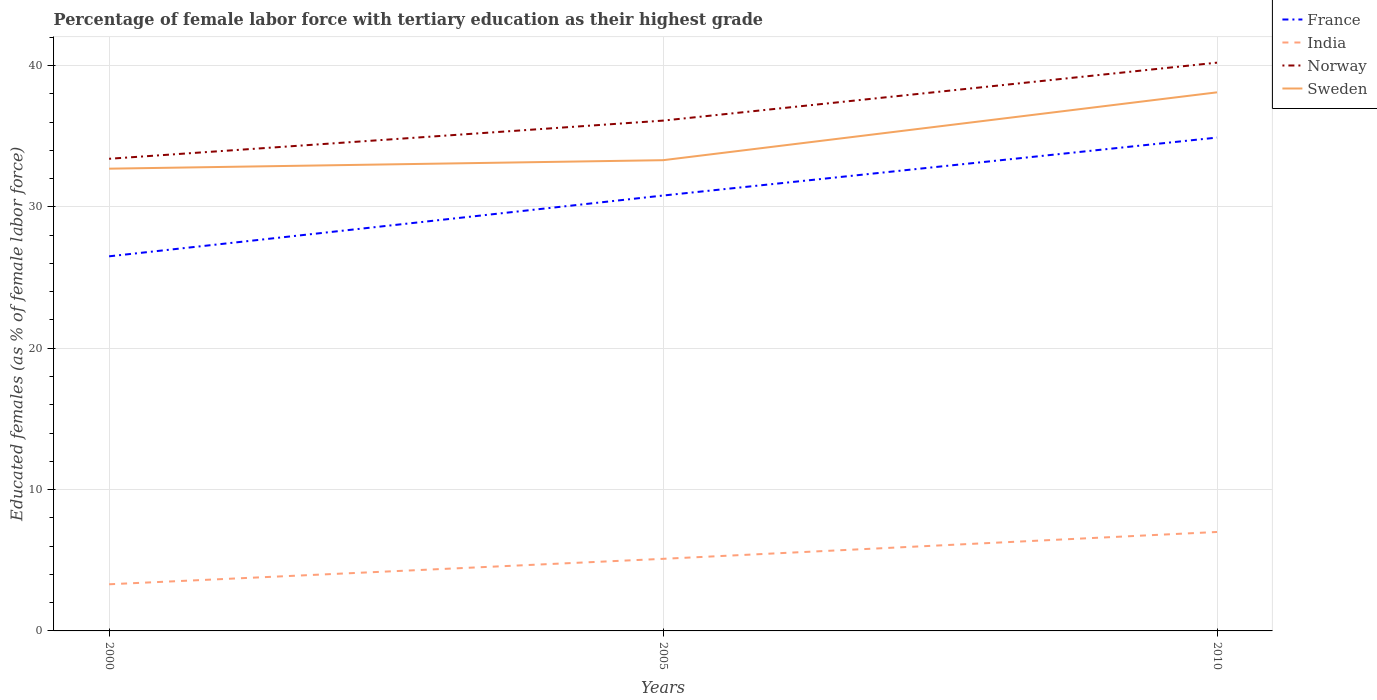Is the number of lines equal to the number of legend labels?
Make the answer very short. Yes. Across all years, what is the maximum percentage of female labor force with tertiary education in Sweden?
Keep it short and to the point. 32.7. In which year was the percentage of female labor force with tertiary education in Norway maximum?
Make the answer very short. 2000. What is the total percentage of female labor force with tertiary education in Sweden in the graph?
Give a very brief answer. -0.6. What is the difference between the highest and the second highest percentage of female labor force with tertiary education in France?
Give a very brief answer. 8.4. What is the difference between the highest and the lowest percentage of female labor force with tertiary education in Norway?
Offer a terse response. 1. Is the percentage of female labor force with tertiary education in India strictly greater than the percentage of female labor force with tertiary education in Sweden over the years?
Keep it short and to the point. Yes. How many lines are there?
Your response must be concise. 4. How many years are there in the graph?
Give a very brief answer. 3. Does the graph contain any zero values?
Your answer should be very brief. No. Does the graph contain grids?
Provide a short and direct response. Yes. Where does the legend appear in the graph?
Provide a succinct answer. Top right. How are the legend labels stacked?
Keep it short and to the point. Vertical. What is the title of the graph?
Provide a short and direct response. Percentage of female labor force with tertiary education as their highest grade. What is the label or title of the Y-axis?
Keep it short and to the point. Educated females (as % of female labor force). What is the Educated females (as % of female labor force) in France in 2000?
Give a very brief answer. 26.5. What is the Educated females (as % of female labor force) of India in 2000?
Provide a short and direct response. 3.3. What is the Educated females (as % of female labor force) of Norway in 2000?
Offer a terse response. 33.4. What is the Educated females (as % of female labor force) of Sweden in 2000?
Make the answer very short. 32.7. What is the Educated females (as % of female labor force) in France in 2005?
Your response must be concise. 30.8. What is the Educated females (as % of female labor force) in India in 2005?
Offer a terse response. 5.1. What is the Educated females (as % of female labor force) in Norway in 2005?
Give a very brief answer. 36.1. What is the Educated females (as % of female labor force) in Sweden in 2005?
Ensure brevity in your answer.  33.3. What is the Educated females (as % of female labor force) of France in 2010?
Offer a terse response. 34.9. What is the Educated females (as % of female labor force) in Norway in 2010?
Your answer should be very brief. 40.2. What is the Educated females (as % of female labor force) of Sweden in 2010?
Provide a succinct answer. 38.1. Across all years, what is the maximum Educated females (as % of female labor force) of France?
Make the answer very short. 34.9. Across all years, what is the maximum Educated females (as % of female labor force) in Norway?
Your response must be concise. 40.2. Across all years, what is the maximum Educated females (as % of female labor force) in Sweden?
Give a very brief answer. 38.1. Across all years, what is the minimum Educated females (as % of female labor force) in India?
Your response must be concise. 3.3. Across all years, what is the minimum Educated females (as % of female labor force) of Norway?
Keep it short and to the point. 33.4. Across all years, what is the minimum Educated females (as % of female labor force) in Sweden?
Your answer should be compact. 32.7. What is the total Educated females (as % of female labor force) in France in the graph?
Your answer should be very brief. 92.2. What is the total Educated females (as % of female labor force) in India in the graph?
Offer a terse response. 15.4. What is the total Educated females (as % of female labor force) in Norway in the graph?
Provide a succinct answer. 109.7. What is the total Educated females (as % of female labor force) of Sweden in the graph?
Make the answer very short. 104.1. What is the difference between the Educated females (as % of female labor force) in France in 2000 and that in 2005?
Ensure brevity in your answer.  -4.3. What is the difference between the Educated females (as % of female labor force) of India in 2000 and that in 2005?
Your response must be concise. -1.8. What is the difference between the Educated females (as % of female labor force) in Sweden in 2000 and that in 2005?
Offer a very short reply. -0.6. What is the difference between the Educated females (as % of female labor force) in France in 2000 and that in 2010?
Make the answer very short. -8.4. What is the difference between the Educated females (as % of female labor force) in France in 2005 and that in 2010?
Make the answer very short. -4.1. What is the difference between the Educated females (as % of female labor force) in Sweden in 2005 and that in 2010?
Make the answer very short. -4.8. What is the difference between the Educated females (as % of female labor force) in France in 2000 and the Educated females (as % of female labor force) in India in 2005?
Keep it short and to the point. 21.4. What is the difference between the Educated females (as % of female labor force) of France in 2000 and the Educated females (as % of female labor force) of Norway in 2005?
Make the answer very short. -9.6. What is the difference between the Educated females (as % of female labor force) of India in 2000 and the Educated females (as % of female labor force) of Norway in 2005?
Offer a terse response. -32.8. What is the difference between the Educated females (as % of female labor force) of India in 2000 and the Educated females (as % of female labor force) of Sweden in 2005?
Offer a very short reply. -30. What is the difference between the Educated females (as % of female labor force) of France in 2000 and the Educated females (as % of female labor force) of Norway in 2010?
Provide a succinct answer. -13.7. What is the difference between the Educated females (as % of female labor force) in France in 2000 and the Educated females (as % of female labor force) in Sweden in 2010?
Provide a short and direct response. -11.6. What is the difference between the Educated females (as % of female labor force) in India in 2000 and the Educated females (as % of female labor force) in Norway in 2010?
Your response must be concise. -36.9. What is the difference between the Educated females (as % of female labor force) in India in 2000 and the Educated females (as % of female labor force) in Sweden in 2010?
Your answer should be very brief. -34.8. What is the difference between the Educated females (as % of female labor force) of Norway in 2000 and the Educated females (as % of female labor force) of Sweden in 2010?
Your answer should be very brief. -4.7. What is the difference between the Educated females (as % of female labor force) of France in 2005 and the Educated females (as % of female labor force) of India in 2010?
Your answer should be very brief. 23.8. What is the difference between the Educated females (as % of female labor force) of France in 2005 and the Educated females (as % of female labor force) of Sweden in 2010?
Make the answer very short. -7.3. What is the difference between the Educated females (as % of female labor force) in India in 2005 and the Educated females (as % of female labor force) in Norway in 2010?
Keep it short and to the point. -35.1. What is the difference between the Educated females (as % of female labor force) in India in 2005 and the Educated females (as % of female labor force) in Sweden in 2010?
Provide a short and direct response. -33. What is the difference between the Educated females (as % of female labor force) in Norway in 2005 and the Educated females (as % of female labor force) in Sweden in 2010?
Keep it short and to the point. -2. What is the average Educated females (as % of female labor force) in France per year?
Ensure brevity in your answer.  30.73. What is the average Educated females (as % of female labor force) of India per year?
Provide a succinct answer. 5.13. What is the average Educated females (as % of female labor force) in Norway per year?
Keep it short and to the point. 36.57. What is the average Educated females (as % of female labor force) in Sweden per year?
Your answer should be very brief. 34.7. In the year 2000, what is the difference between the Educated females (as % of female labor force) of France and Educated females (as % of female labor force) of India?
Provide a short and direct response. 23.2. In the year 2000, what is the difference between the Educated females (as % of female labor force) in India and Educated females (as % of female labor force) in Norway?
Provide a short and direct response. -30.1. In the year 2000, what is the difference between the Educated females (as % of female labor force) of India and Educated females (as % of female labor force) of Sweden?
Provide a short and direct response. -29.4. In the year 2000, what is the difference between the Educated females (as % of female labor force) in Norway and Educated females (as % of female labor force) in Sweden?
Your response must be concise. 0.7. In the year 2005, what is the difference between the Educated females (as % of female labor force) in France and Educated females (as % of female labor force) in India?
Keep it short and to the point. 25.7. In the year 2005, what is the difference between the Educated females (as % of female labor force) in France and Educated females (as % of female labor force) in Norway?
Give a very brief answer. -5.3. In the year 2005, what is the difference between the Educated females (as % of female labor force) of France and Educated females (as % of female labor force) of Sweden?
Provide a succinct answer. -2.5. In the year 2005, what is the difference between the Educated females (as % of female labor force) of India and Educated females (as % of female labor force) of Norway?
Your response must be concise. -31. In the year 2005, what is the difference between the Educated females (as % of female labor force) of India and Educated females (as % of female labor force) of Sweden?
Offer a very short reply. -28.2. In the year 2010, what is the difference between the Educated females (as % of female labor force) of France and Educated females (as % of female labor force) of India?
Provide a succinct answer. 27.9. In the year 2010, what is the difference between the Educated females (as % of female labor force) in India and Educated females (as % of female labor force) in Norway?
Your answer should be very brief. -33.2. In the year 2010, what is the difference between the Educated females (as % of female labor force) of India and Educated females (as % of female labor force) of Sweden?
Provide a short and direct response. -31.1. In the year 2010, what is the difference between the Educated females (as % of female labor force) in Norway and Educated females (as % of female labor force) in Sweden?
Make the answer very short. 2.1. What is the ratio of the Educated females (as % of female labor force) of France in 2000 to that in 2005?
Ensure brevity in your answer.  0.86. What is the ratio of the Educated females (as % of female labor force) in India in 2000 to that in 2005?
Offer a terse response. 0.65. What is the ratio of the Educated females (as % of female labor force) of Norway in 2000 to that in 2005?
Make the answer very short. 0.93. What is the ratio of the Educated females (as % of female labor force) of France in 2000 to that in 2010?
Offer a terse response. 0.76. What is the ratio of the Educated females (as % of female labor force) in India in 2000 to that in 2010?
Your response must be concise. 0.47. What is the ratio of the Educated females (as % of female labor force) of Norway in 2000 to that in 2010?
Your response must be concise. 0.83. What is the ratio of the Educated females (as % of female labor force) of Sweden in 2000 to that in 2010?
Your answer should be very brief. 0.86. What is the ratio of the Educated females (as % of female labor force) of France in 2005 to that in 2010?
Your answer should be compact. 0.88. What is the ratio of the Educated females (as % of female labor force) of India in 2005 to that in 2010?
Give a very brief answer. 0.73. What is the ratio of the Educated females (as % of female labor force) of Norway in 2005 to that in 2010?
Give a very brief answer. 0.9. What is the ratio of the Educated females (as % of female labor force) in Sweden in 2005 to that in 2010?
Provide a short and direct response. 0.87. What is the difference between the highest and the second highest Educated females (as % of female labor force) of India?
Provide a succinct answer. 1.9. What is the difference between the highest and the second highest Educated females (as % of female labor force) of Norway?
Your response must be concise. 4.1. What is the difference between the highest and the lowest Educated females (as % of female labor force) in France?
Keep it short and to the point. 8.4. What is the difference between the highest and the lowest Educated females (as % of female labor force) in Sweden?
Offer a very short reply. 5.4. 